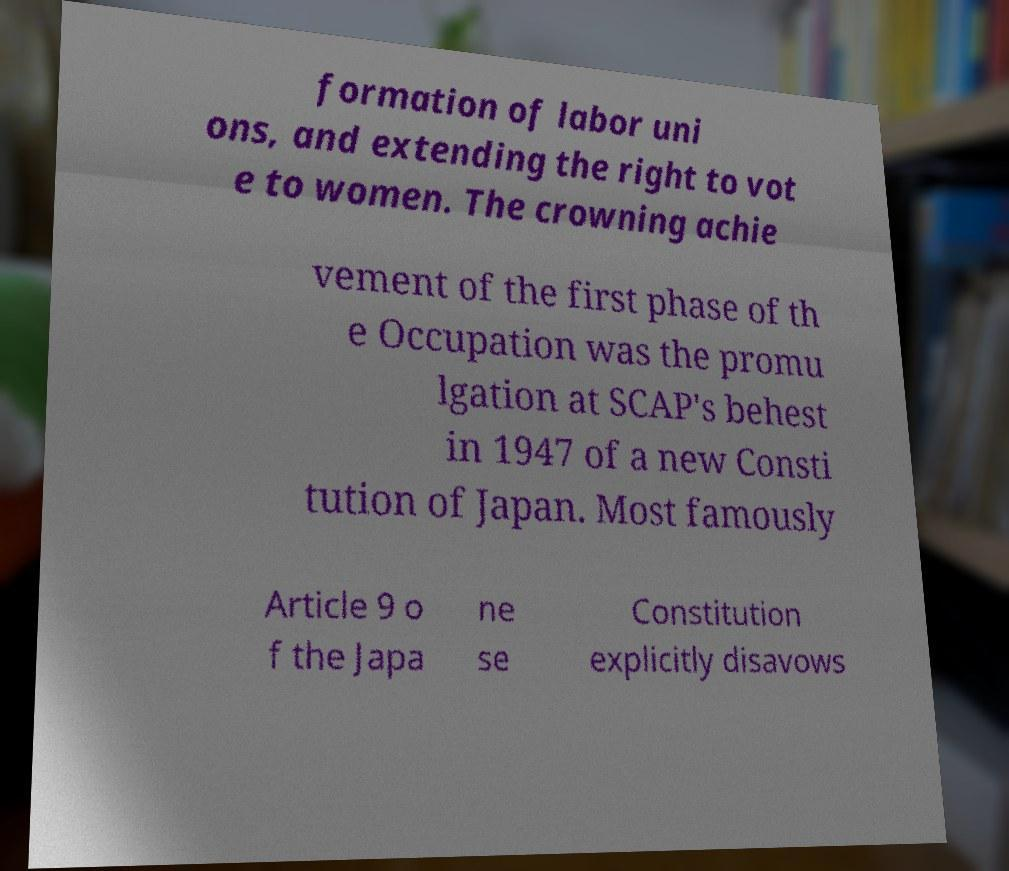Could you extract and type out the text from this image? formation of labor uni ons, and extending the right to vot e to women. The crowning achie vement of the first phase of th e Occupation was the promu lgation at SCAP's behest in 1947 of a new Consti tution of Japan. Most famously Article 9 o f the Japa ne se Constitution explicitly disavows 